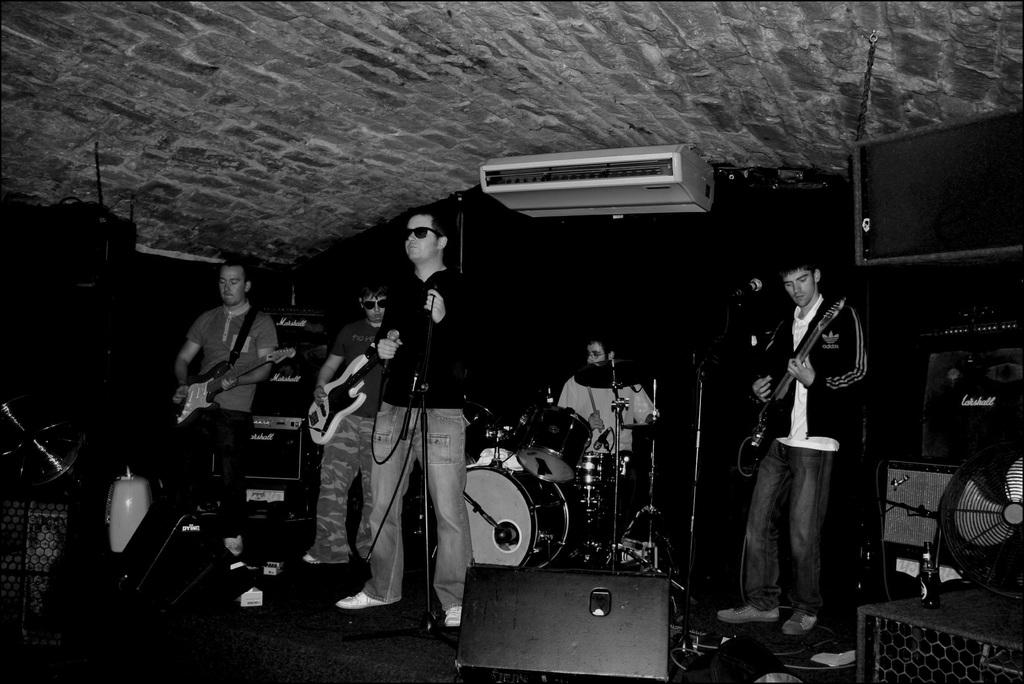What are the people in the image doing? There is a group of persons playing musical instruments in the image. What can be seen on the right side of the image? There is a table fan on the right side of the image. Can you describe the object at the bottom of the image? There is a sound box at the bottom of the image. What type of clover is growing on the table fan in the image? There is no clover present in the image, and the table fan is not a plant or a place where plants would grow. 